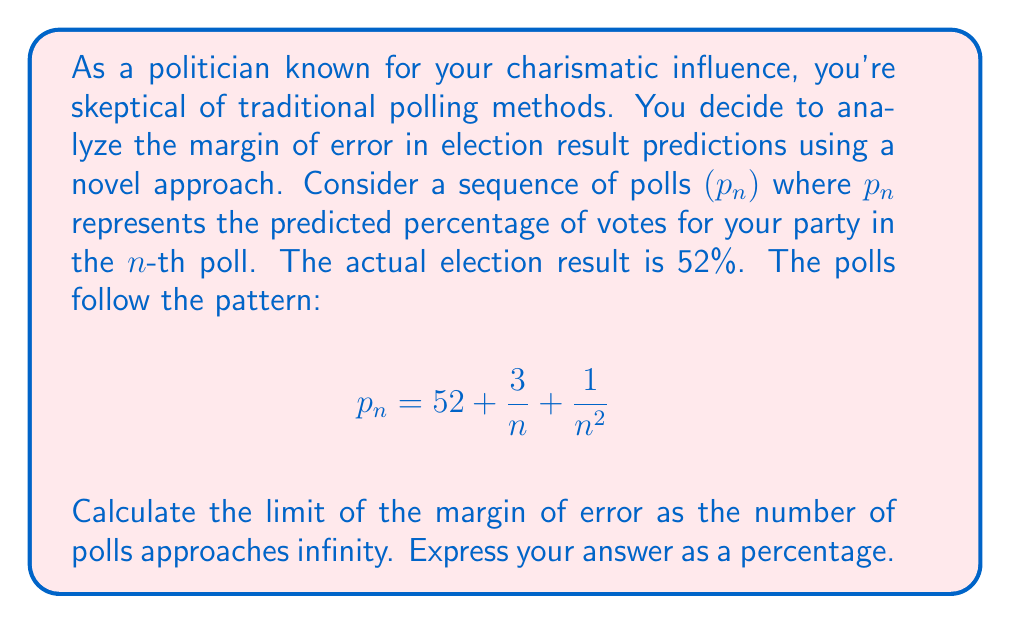Provide a solution to this math problem. Let's approach this step-by-step:

1) The margin of error is the absolute difference between the predicted value and the actual value. In this case, the actual value is 52%.

2) For the $n$-th poll, the margin of error is:
   $$|p_n - 52| = \left|\left(52 + \frac{3}{n} + \frac{1}{n^2}\right) - 52\right| = \left|\frac{3}{n} + \frac{1}{n^2}\right|$$

3) To find the limit of the margin of error as $n$ approaches infinity, we need to calculate:
   $$\lim_{n \to \infty} \left|\frac{3}{n} + \frac{1}{n^2}\right|$$

4) Let's evaluate this limit:
   $$\lim_{n \to \infty} \left|\frac{3}{n} + \frac{1}{n^2}\right| = \left|\lim_{n \to \infty} \frac{3}{n} + \lim_{n \to \infty} \frac{1}{n^2}\right|$$

5) We know that:
   $$\lim_{n \to \infty} \frac{3}{n} = 0 \text{ and } \lim_{n \to \infty} \frac{1}{n^2} = 0$$

6) Therefore:
   $$\lim_{n \to \infty} \left|\frac{3}{n} + \frac{1}{n^2}\right| = |0 + 0| = 0$$

7) To express this as a percentage, we multiply by 100:
   $$0 \times 100 = 0\%$$

Thus, as the number of polls approaches infinity, the margin of error approaches 0%.
Answer: 0% 